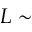Convert formula to latex. <formula><loc_0><loc_0><loc_500><loc_500>L \sim</formula> 